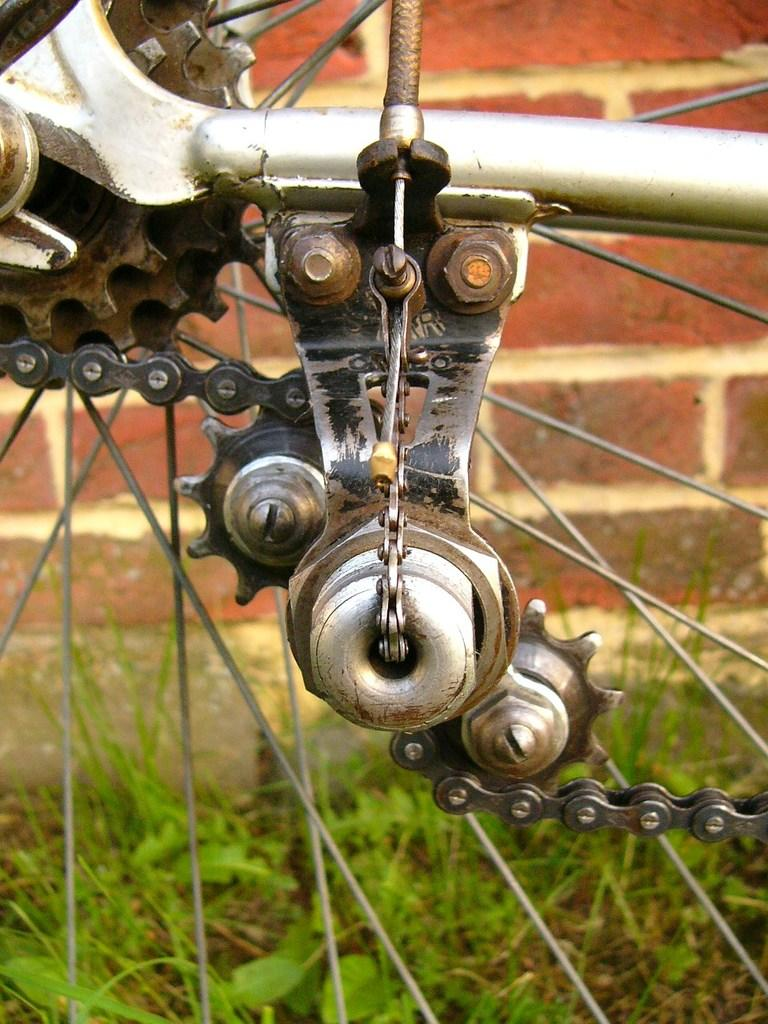What is the main object in the image? There is a bicycle wheel in the image. What other object can be seen in the image? There is a chair in the image. What type of natural environment is visible in the background? There is grass in the background of the image. What type of structure is visible in the background? There is a brown color brick wall in the background of the image. How does the button increase the speed of the bicycle wheel in the image? There is no button present in the image, and therefore no such interaction can be observed. 